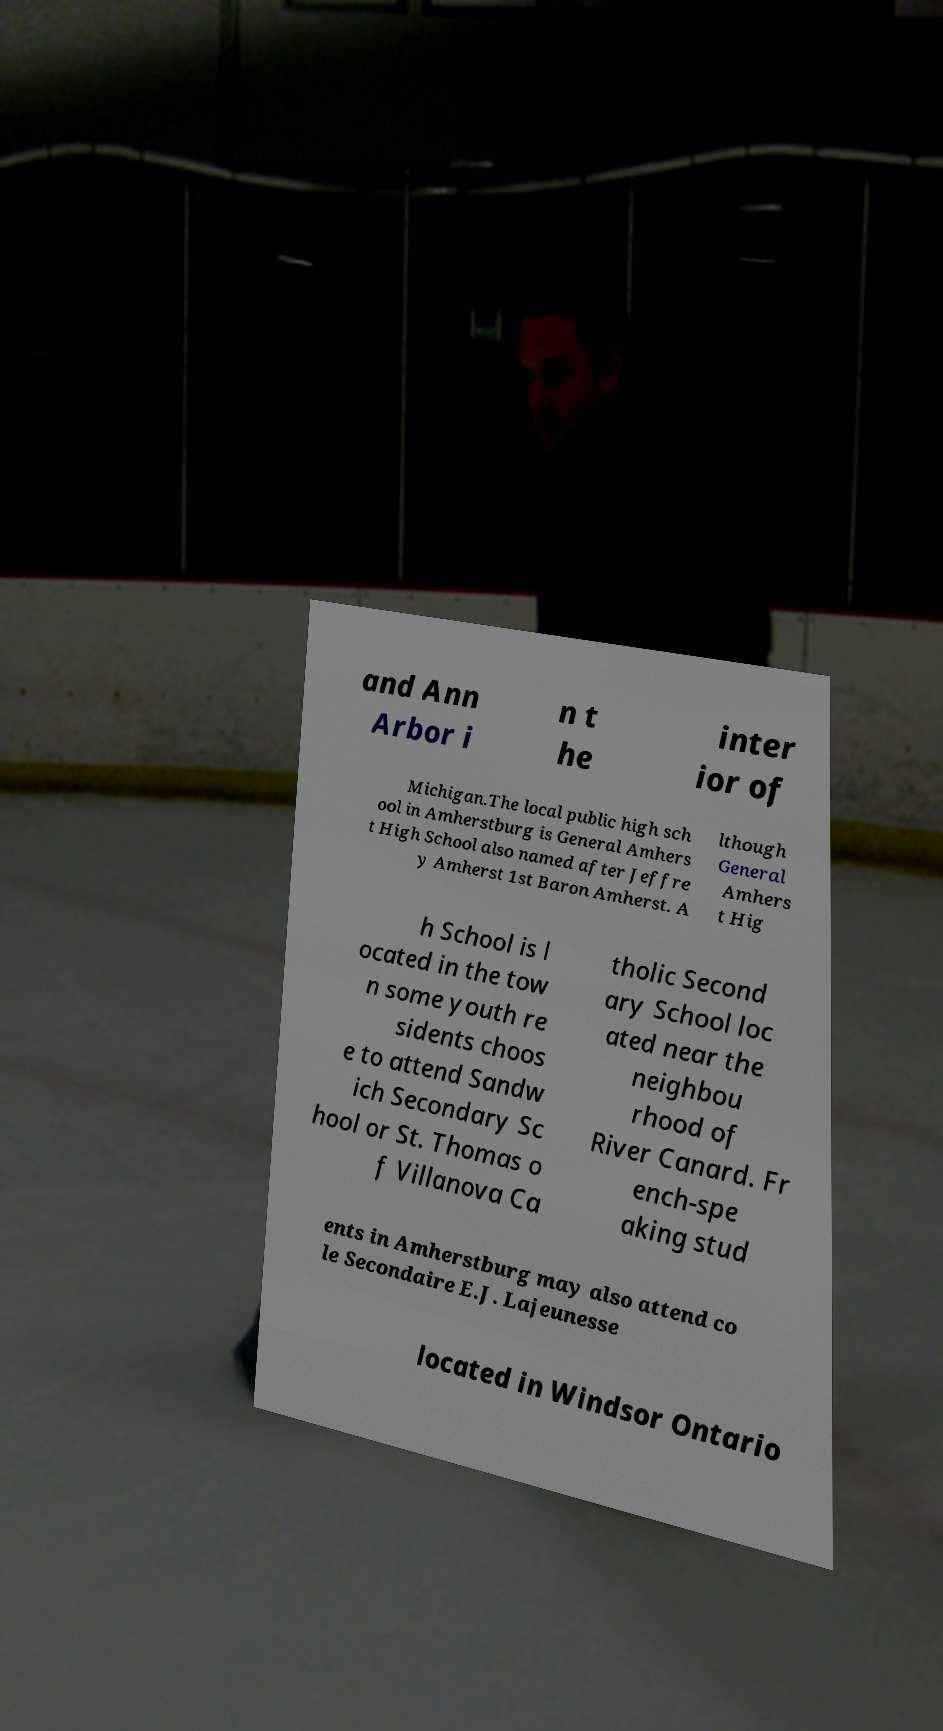Can you read and provide the text displayed in the image?This photo seems to have some interesting text. Can you extract and type it out for me? and Ann Arbor i n t he inter ior of Michigan.The local public high sch ool in Amherstburg is General Amhers t High School also named after Jeffre y Amherst 1st Baron Amherst. A lthough General Amhers t Hig h School is l ocated in the tow n some youth re sidents choos e to attend Sandw ich Secondary Sc hool or St. Thomas o f Villanova Ca tholic Second ary School loc ated near the neighbou rhood of River Canard. Fr ench-spe aking stud ents in Amherstburg may also attend co le Secondaire E.J. Lajeunesse located in Windsor Ontario 